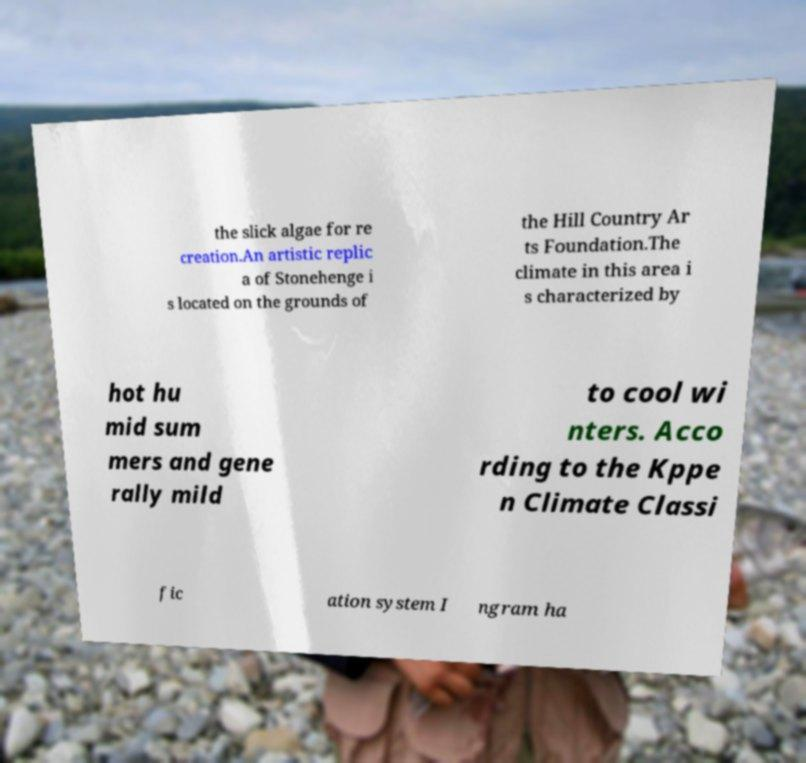Please identify and transcribe the text found in this image. the slick algae for re creation.An artistic replic a of Stonehenge i s located on the grounds of the Hill Country Ar ts Foundation.The climate in this area i s characterized by hot hu mid sum mers and gene rally mild to cool wi nters. Acco rding to the Kppe n Climate Classi fic ation system I ngram ha 